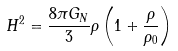Convert formula to latex. <formula><loc_0><loc_0><loc_500><loc_500>H ^ { 2 } = \frac { 8 \pi G _ { N } } { 3 } \rho \left ( 1 + \frac { \rho } { \rho _ { 0 } } \right )</formula> 